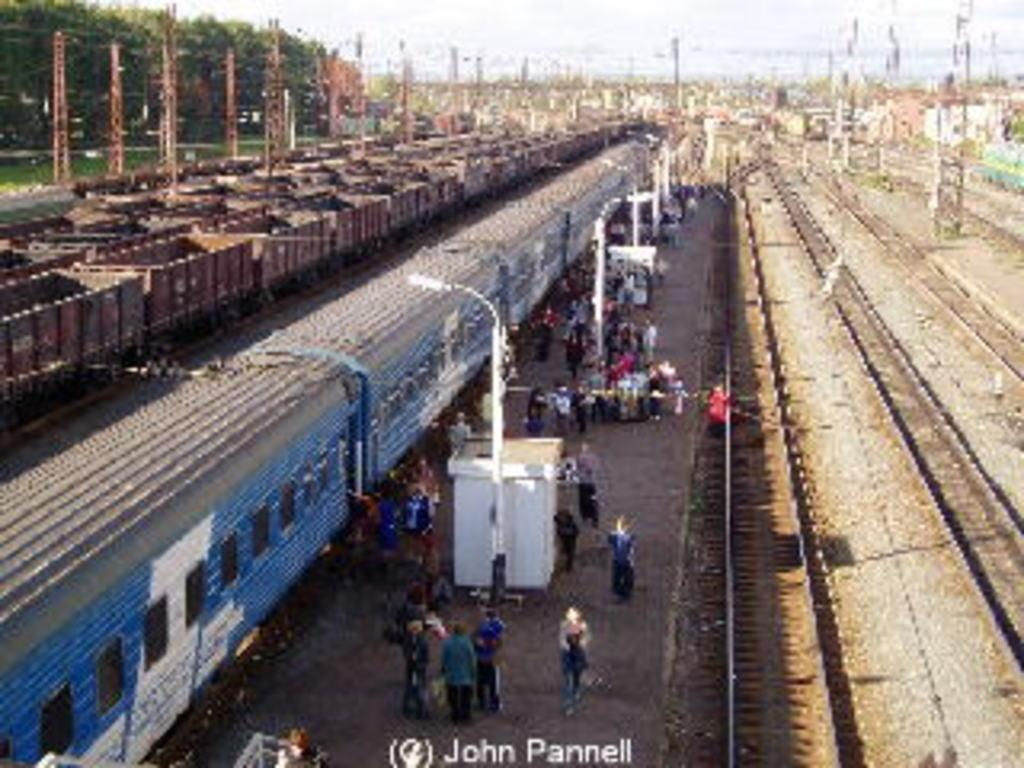What can be seen in the image? There are people and trains in the image. What are the trains situated on? There are tracks in the image, and the trains are situated on them. What type of infrastructure is present in the image? There are lights on poles in the image. What can be seen in the background of the image? Trees and the sky are visible in the background of the image. What color is the polish used by the people in the image? There is no mention of polish or any activity involving polish in the image. 